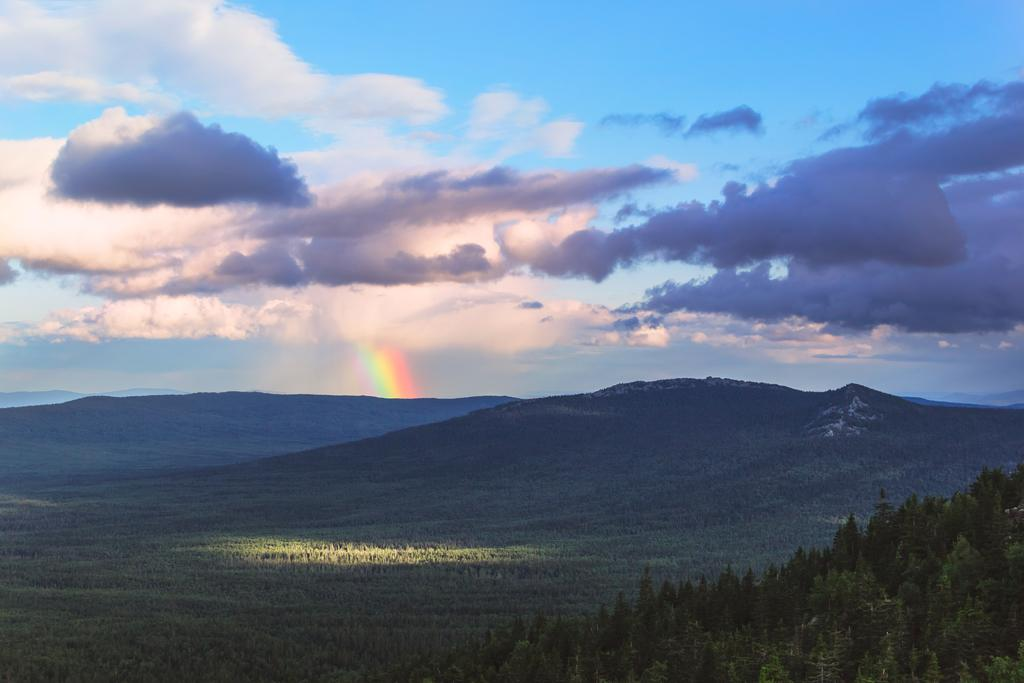What type of vegetation can be seen in the image? There are trees in the image. What geographical features are present in the image? There are hills in the image. What can be seen in the sky in the image? There is a rainbow and clouds in the sky in the image. How many pizzas are being smashed by the trees in the image? There are no pizzas or smashing depicted in the image; it features trees, hills, and a sky with a rainbow and clouds. 